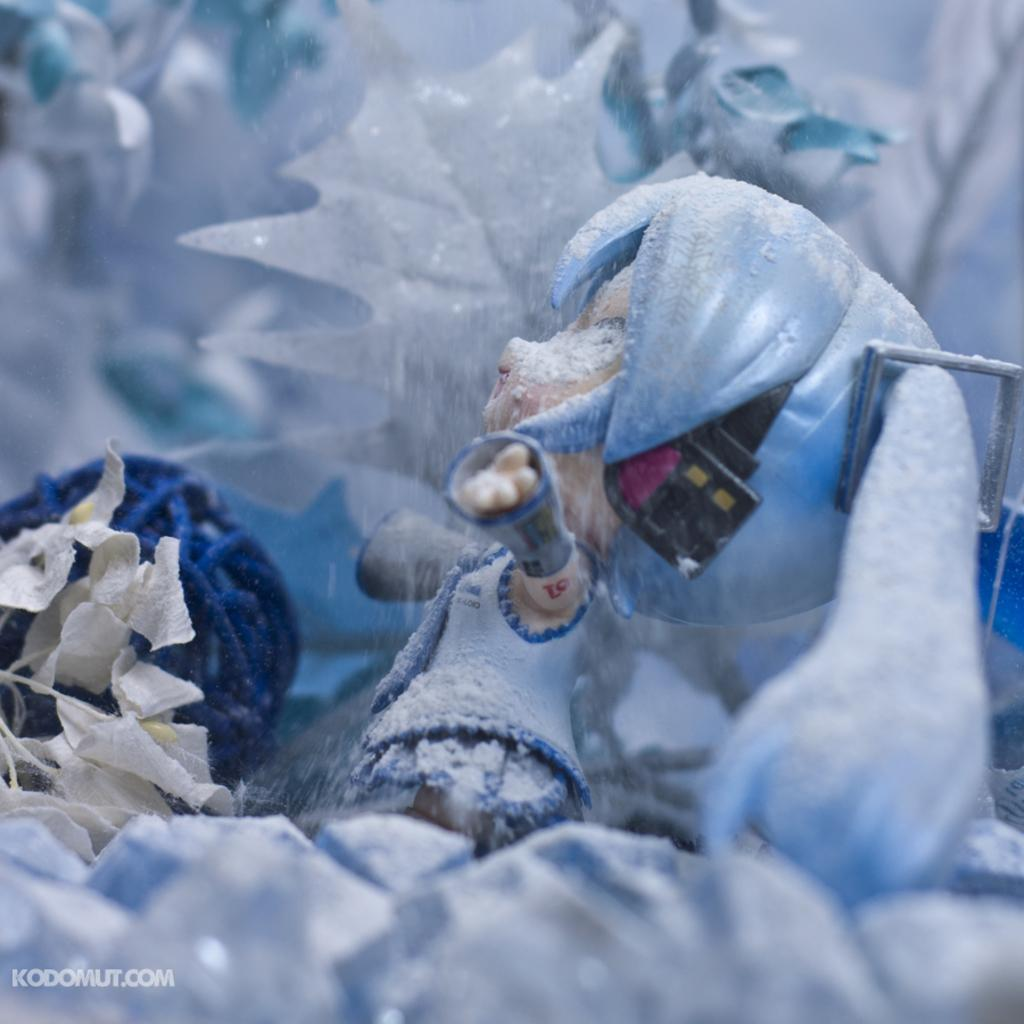What object can be seen in the image that is meant for play or entertainment? There is a toy in the image. Is there any text or logo visible in the image? Yes, there is a watermark in the image. What type of ice can be seen forming in the image? There is no ice present in the image. Can you describe the baseball game happening in the image? There is no baseball game or any reference to baseball in the image. 